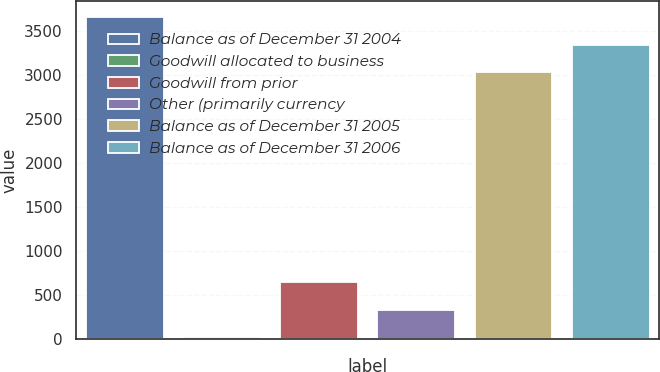Convert chart to OTSL. <chart><loc_0><loc_0><loc_500><loc_500><bar_chart><fcel>Balance as of December 31 2004<fcel>Goodwill allocated to business<fcel>Goodwill from prior<fcel>Other (primarily currency<fcel>Balance as of December 31 2005<fcel>Balance as of December 31 2006<nl><fcel>3654.04<fcel>25.9<fcel>649.04<fcel>337.47<fcel>3030.9<fcel>3342.47<nl></chart> 